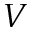Convert formula to latex. <formula><loc_0><loc_0><loc_500><loc_500>V</formula> 